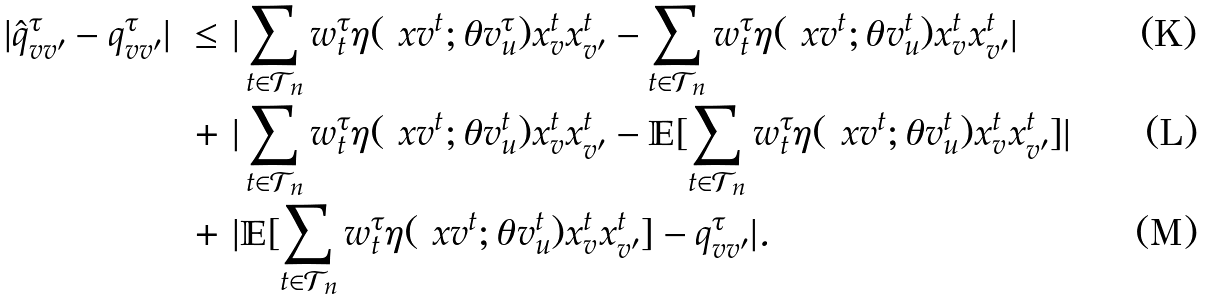Convert formula to latex. <formula><loc_0><loc_0><loc_500><loc_500>| \hat { q } _ { v v ^ { \prime } } ^ { \tau } - q _ { v v ^ { \prime } } ^ { \tau } | \ \leq & \ | \sum _ { t \in \mathcal { T } _ { n } } w _ { t } ^ { \tau } \eta ( \ x v ^ { t } ; \theta v _ { u } ^ { \tau } ) x _ { v } ^ { t } x _ { v ^ { \prime } } ^ { t } - \sum _ { t \in \mathcal { T } _ { n } } w _ { t } ^ { \tau } \eta ( \ x v ^ { t } ; \theta v _ { u } ^ { t } ) x _ { v } ^ { t } x _ { v ^ { \prime } } ^ { t } | \\ + & \ | \sum _ { t \in \mathcal { T } _ { n } } w _ { t } ^ { \tau } \eta ( \ x v ^ { t } ; \theta v _ { u } ^ { t } ) x _ { v } ^ { t } x _ { v ^ { \prime } } ^ { t } - \mathbb { E } [ \sum _ { t \in \mathcal { T } _ { n } } w _ { t } ^ { \tau } \eta ( \ x v ^ { t } ; \theta v _ { u } ^ { t } ) x _ { v } ^ { t } x _ { v ^ { \prime } } ^ { t } ] | \\ + & \ | \mathbb { E } [ \sum _ { t \in \mathcal { T } _ { n } } w _ { t } ^ { \tau } \eta ( \ x v ^ { t } ; \theta v _ { u } ^ { t } ) x _ { v } ^ { t } x _ { v ^ { \prime } } ^ { t } ] - q _ { v v ^ { \prime } } ^ { \tau } | .</formula> 